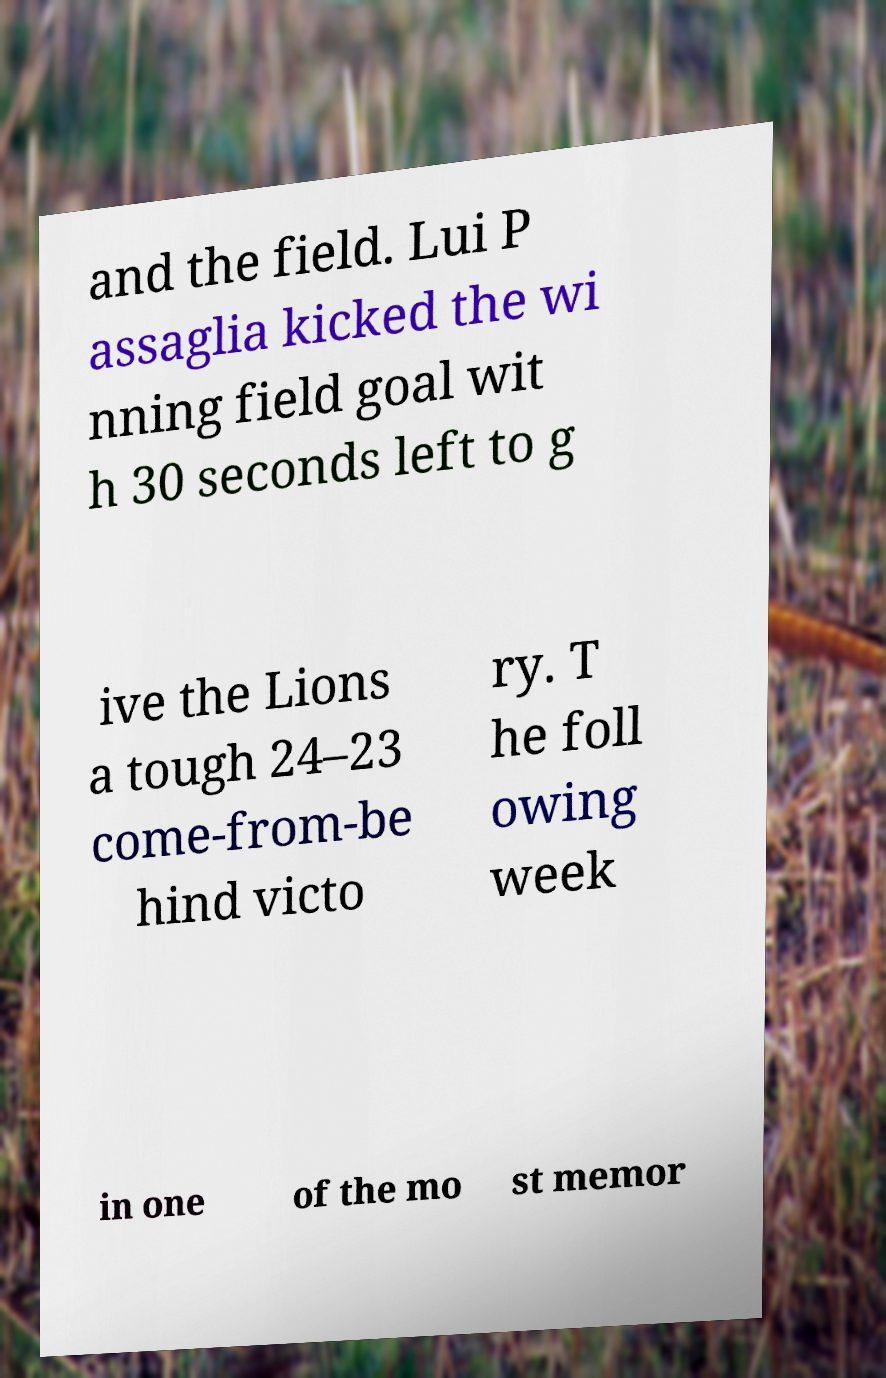Can you read and provide the text displayed in the image?This photo seems to have some interesting text. Can you extract and type it out for me? and the field. Lui P assaglia kicked the wi nning field goal wit h 30 seconds left to g ive the Lions a tough 24–23 come-from-be hind victo ry. T he foll owing week in one of the mo st memor 